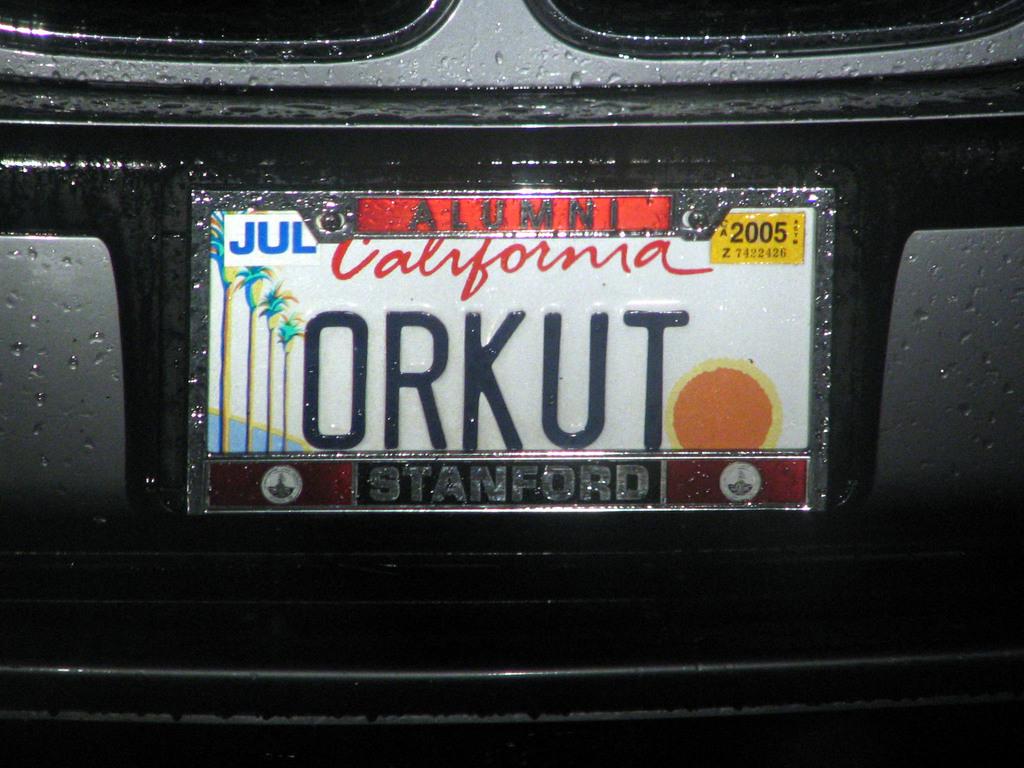What state is this car from?
Your response must be concise. California. 